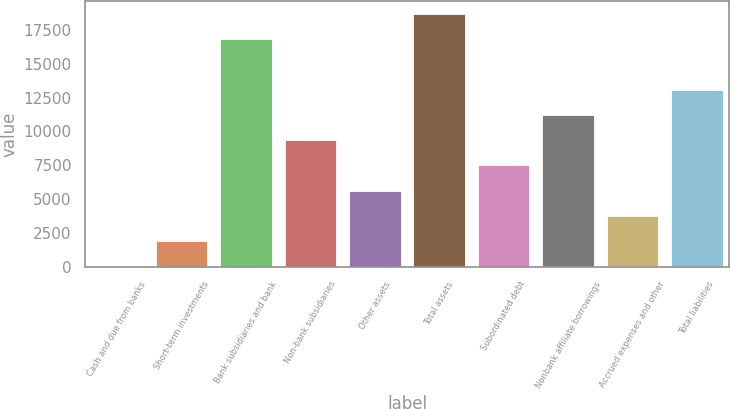<chart> <loc_0><loc_0><loc_500><loc_500><bar_chart><fcel>Cash and due from banks<fcel>Short-term investments<fcel>Bank subsidiaries and bank<fcel>Non-bank subsidiaries<fcel>Other assets<fcel>Total assets<fcel>Subordinated debt<fcel>Nonbank affiliate borrowings<fcel>Accrued expenses and other<fcel>Total liabilities<nl><fcel>20<fcel>1886.2<fcel>16815.8<fcel>9351<fcel>5618.6<fcel>18682<fcel>7484.8<fcel>11217.2<fcel>3752.4<fcel>13083.4<nl></chart> 